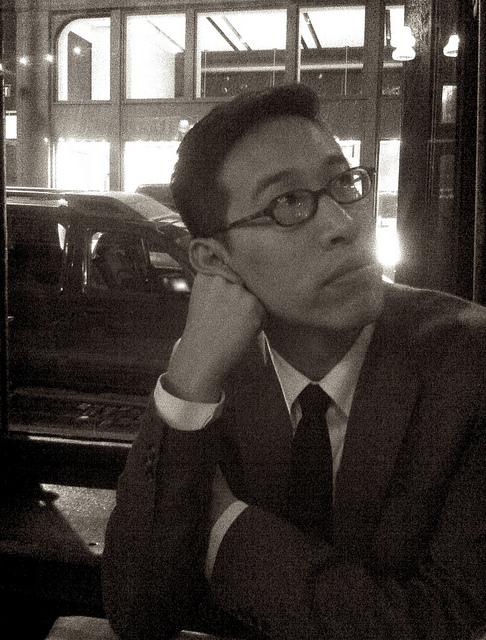What color are the paper lanterns?
Quick response, please. White. What is on the man's face?
Write a very short answer. Glasses. Is this man wearing a tie?
Give a very brief answer. Yes. Is the man waiting?
Keep it brief. Yes. 